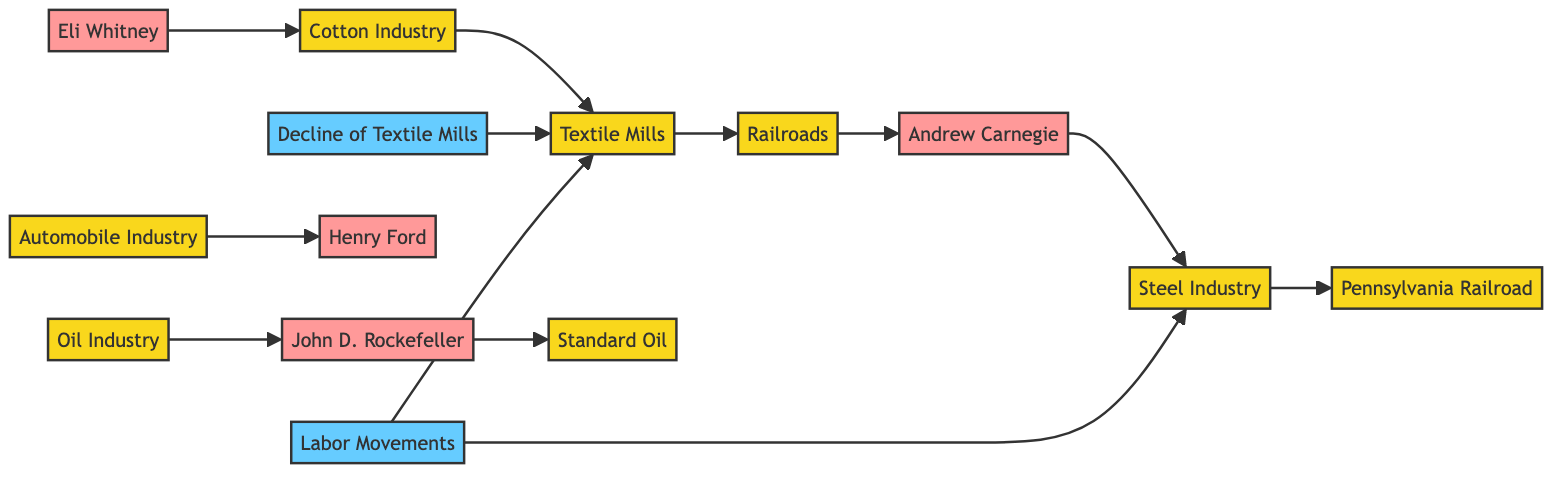What are the key industries represented in the diagram? The nodes for key industries are "Cotton Industry," "Textile Mills," "Railroads," "Steel Industry," "Oil Industry," and "Automobile Industry." These industries can be identified by looking at nodes labeled as industries in the diagram.
Answer: Cotton Industry, Textile Mills, Railroads, Steel Industry, Oil Industry, Automobile Industry Who is connected to the Cotton Industry? The Cotton Industry connects to the Textile Mills (directly) and Eli Whitney (as an influencer). By following the arrows from the Cotton Industry node, both of these connections can be clearly identified in the diagram.
Answer: Textile Mills, Eli Whitney What is indicated by the edge from Labor Movements to Textile Mills? The edge from Labor Movements to Textile Mills suggests a relationship where Labor Movements have had an impact on the Textile Mills, likely relating to labor regulations or changes during the decline of the industry. Analyzing the direction of the arrow helps us understand the flow of influence.
Answer: Influence How many total nodes are present in this directed graph? By counting every unique node mentioned in the provided data, there are a total of 14 nodes. Simply tallying each entry in the nodes array gives us this total.
Answer: 14 Which person is linked to the Steel Industry? Andrew Carnegie is linked to the Steel Industry. Following the arrows, we can see the connection from Carnegie to the Steel Industry directly through the edge that points from Carnegie to Steel.
Answer: Andrew Carnegie How do Labor Movements relate to the Steel Industry? Labor Movements have a directed edge pointing towards the Steel Industry, indicating that Labor Movements have influenced or affected the Steel Industry. Tracking the flow of arrows reveals this connection, demonstrating how labor advocacy relates to industry.
Answer: Influence What is the significance of the connection between Standard Oil and John D. Rockefeller? The connection indicates that John D. Rockefeller is directly associated with Standard Oil, suggesting that he played a key role in that company’s development and success. The direct edge from Rockefeller to Standard Oil in the graph illustrates this relationship.
Answer: Key Role Which industry shows a decline as indicated by the diagram? The diagram indicates the decline of the Textile Mills, as noted by the “Decline of Textile Mills” node that points back to the Textile Mills node. This shows the effect of the decline on the industry itself.
Answer: Textile Mills 